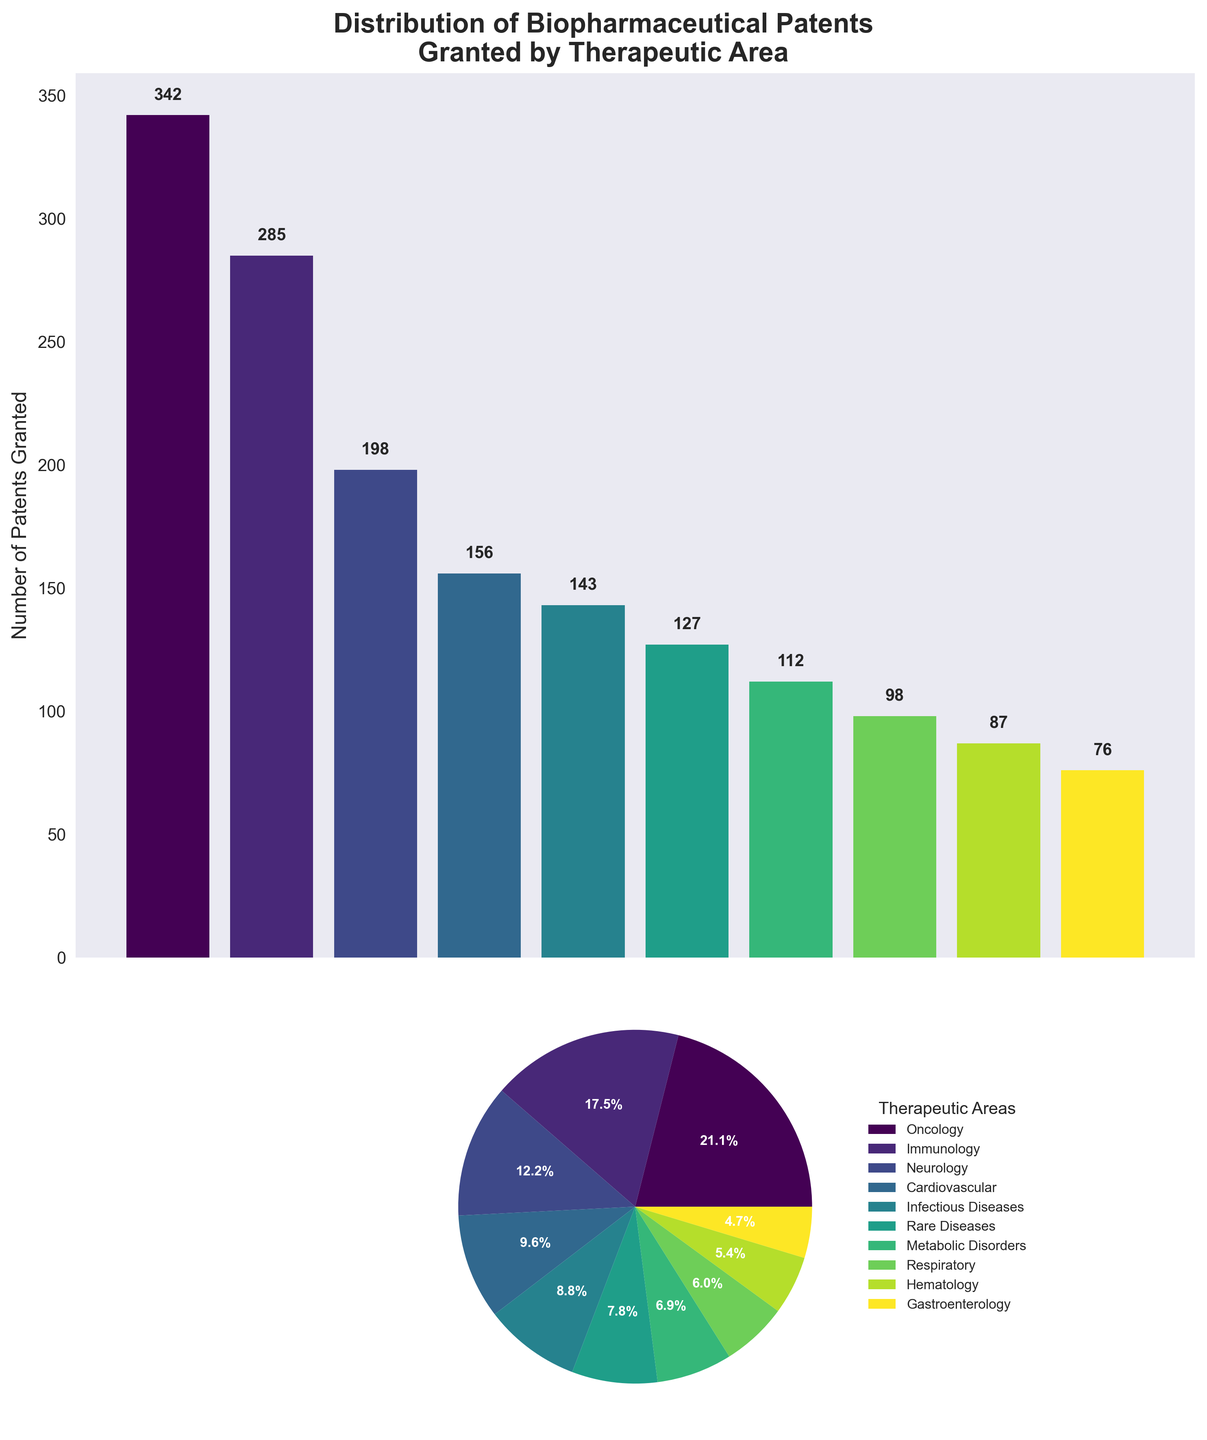How many therapeutic areas have more than 150 patents granted? The bar chart section shows the number of patents granted for each therapeutic area. Count the number of bars that represent a value greater than 150.
Answer: 4 Which therapeutic area has the fewest patents granted? Look at the bar chart and find the bar with the lowest height and its label. Alternatively, in the pie chart, find the smallest wedge and its corresponding label.
Answer: Gastroenterology Which therapeutic area has the highest percentage of patents granted? In the pie chart, locate the wedge with the highest percentage value. Alternatively, in the bar chart, find the bar with the greatest height.
Answer: Oncology How many more patents are granted in Oncology compared to Gastroenterology? Subtract the number of patents granted in Gastroenterology (76) from the number of patents granted in Oncology (342).
Answer: 266 What is the total number of patents granted for Immunology and Neurology combined? Add the number of patents granted in Immunology (285) and Neurology (198).
Answer: 483 Which therapeutic area has about 10% of the total patents granted? In the pie chart, identify the wedge that has a label close to 10%. Alternatively, compute 10% of the total number of patents and compare it with individual patent counts.
Answer: Infectious Diseases How do the numbers of patents for Cardiovascular and Respiratory compare? Look at the bar chart to compare the heights of the bars for Cardiovascular and Respiratory, or check the pie chart for their respective wedges.
Answer: Cardiovascular has more What is the average number of patents granted across all therapeutic areas shown? Sum the number of patents for all therapeutic areas and divide by the number of therapeutic areas (10). (342 + 285 + 198 + 156 + 143 + 127 + 112 + 98 + 87 + 76) / 10 = 1624 / 10
Answer: 162 Is there any therapeutic area that has exactly double the number of patents as another area? Compare the number of patents granted for each therapeutic area to see if any number is exactly double another. Specifically, check each pair of areas to see if one is double the other.
Answer: No 